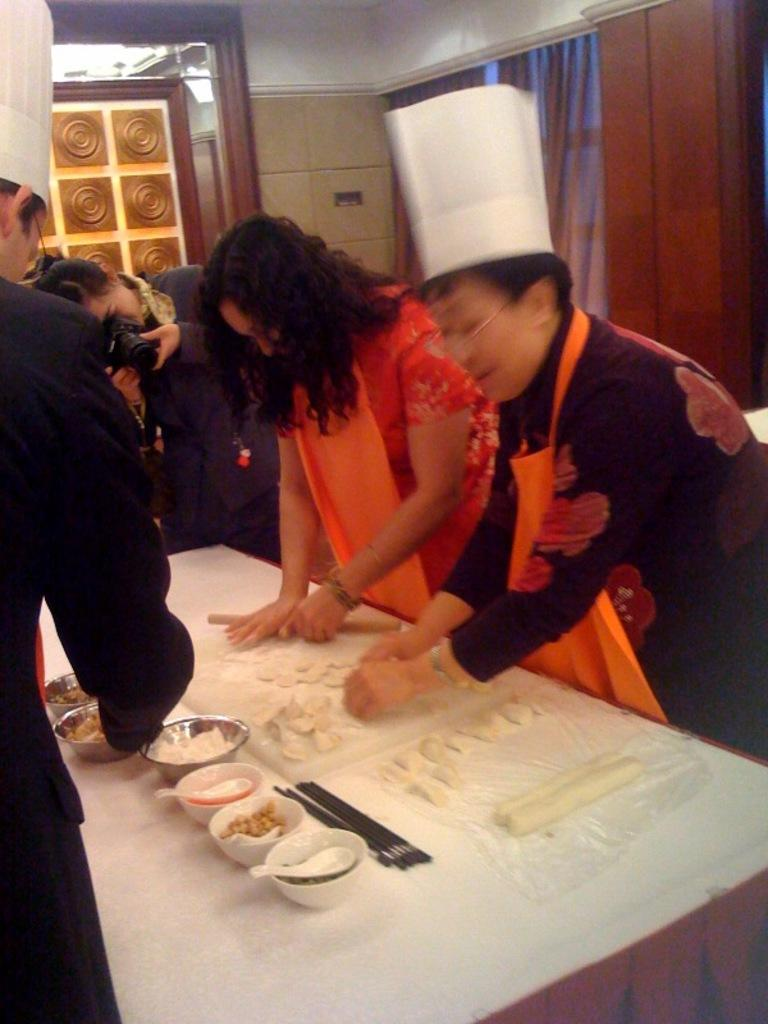What are the people in the image doing? The people in the image are standing and preparing food on a table. Can you describe the woman in the image? The woman is holding a camera and clicking a picture. What can be seen in the background of the image? There is a door and a curtain in the background of the image. What type of glove is the woman wearing while taking the picture? There is no glove visible in the image; the woman is holding a camera with her bare hands. 